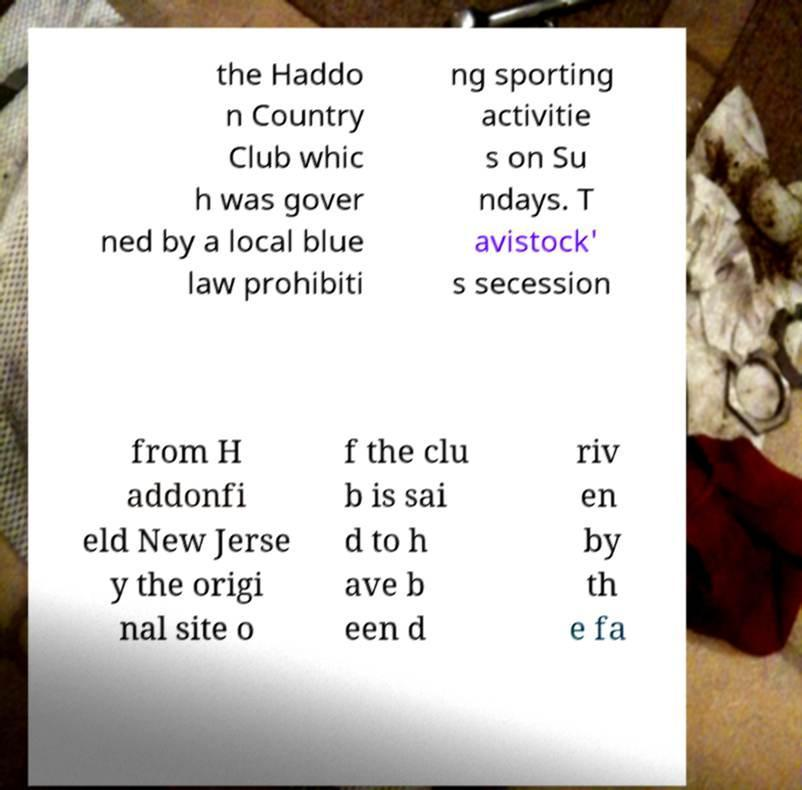Can you accurately transcribe the text from the provided image for me? the Haddo n Country Club whic h was gover ned by a local blue law prohibiti ng sporting activitie s on Su ndays. T avistock' s secession from H addonfi eld New Jerse y the origi nal site o f the clu b is sai d to h ave b een d riv en by th e fa 